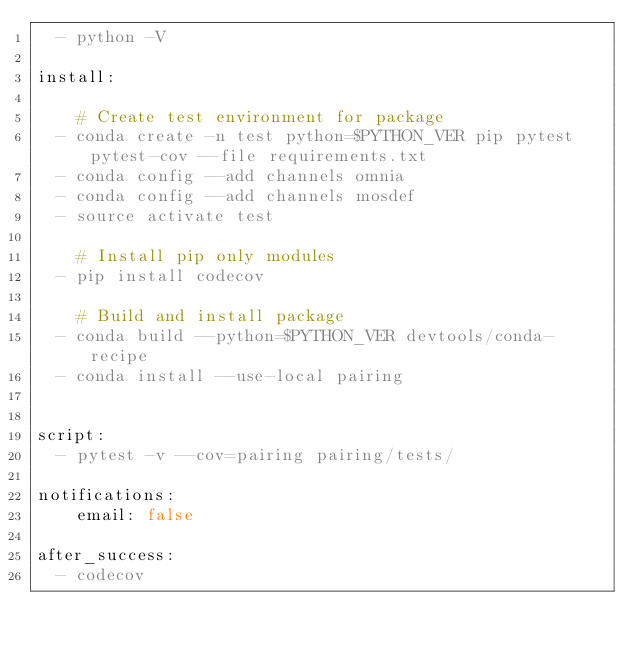<code> <loc_0><loc_0><loc_500><loc_500><_YAML_>  - python -V

install:

    # Create test environment for package
  - conda create -n test python=$PYTHON_VER pip pytest pytest-cov --file requirements.txt
  - conda config --add channels omnia
  - conda config --add channels mosdef
  - source activate test

    # Install pip only modules
  - pip install codecov

    # Build and install package
  - conda build --python=$PYTHON_VER devtools/conda-recipe
  - conda install --use-local pairing


script:
  - pytest -v --cov=pairing pairing/tests/

notifications:
    email: false

after_success:
  - codecov
</code> 